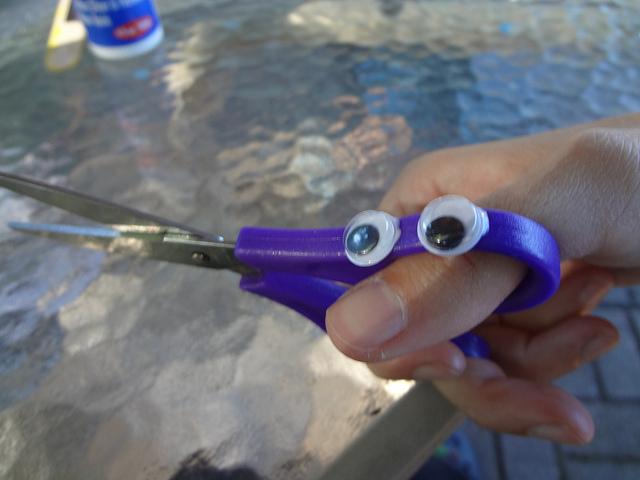What is black and white in the picture?
Quick response, please. Eyes. What is the surface below the scissors?
Keep it brief. Glass. Why are the scissor handles purple?
Short answer required. Fun. 